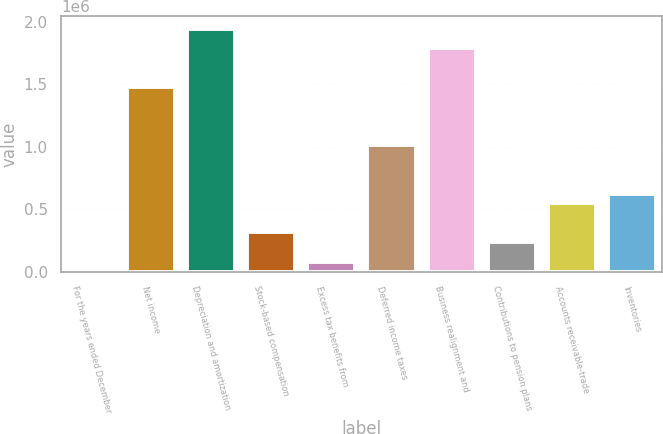<chart> <loc_0><loc_0><loc_500><loc_500><bar_chart><fcel>For the years ended December<fcel>Net income<fcel>Depreciation and amortization<fcel>Stock-based compensation<fcel>Excess tax benefits from<fcel>Deferred income taxes<fcel>Business realignment and<fcel>Contributions to pension plans<fcel>Accounts receivable-trade<fcel>Inventories<nl><fcel>2007<fcel>1.47798e+06<fcel>1.94408e+06<fcel>312739<fcel>79689.9<fcel>1.01188e+06<fcel>1.78871e+06<fcel>235056<fcel>545787<fcel>623470<nl></chart> 